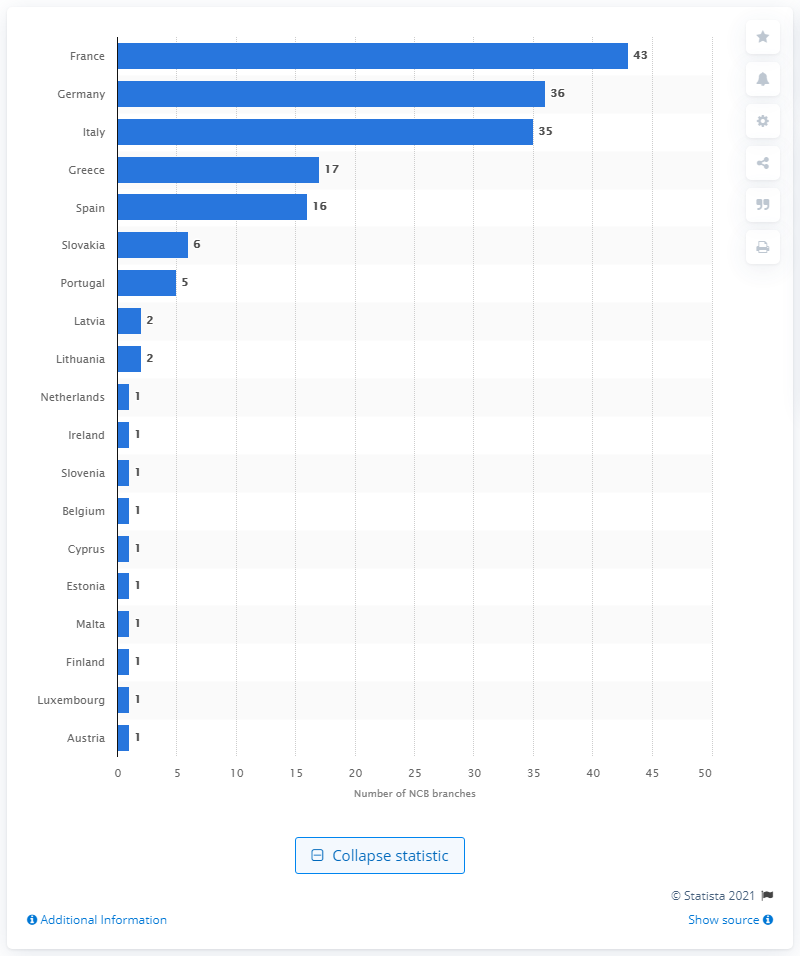Outline some significant characteristics in this image. At the end of December 2019, France had a total of 43 National Central Bank branches. France had the largest number of National Central Bank branches. 